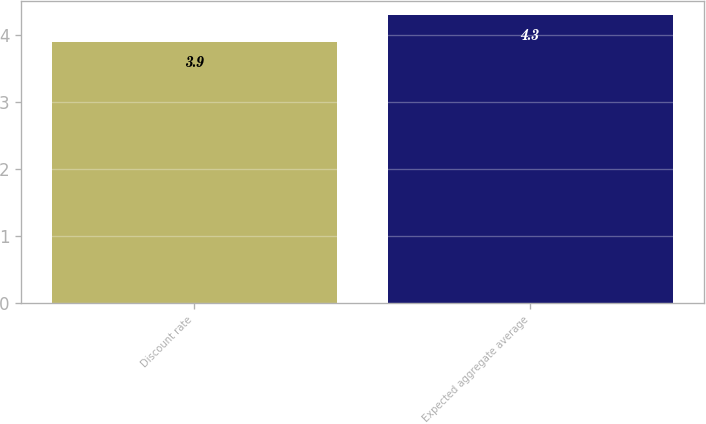Convert chart. <chart><loc_0><loc_0><loc_500><loc_500><bar_chart><fcel>Discount rate<fcel>Expected aggregate average<nl><fcel>3.9<fcel>4.3<nl></chart> 